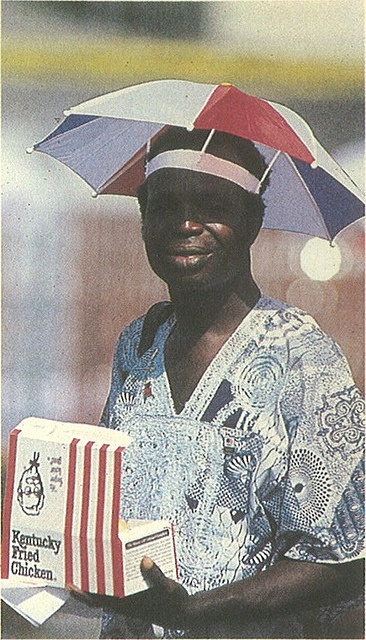Describe the objects in this image and their specific colors. I can see people in lightyellow, gray, lightgray, darkgray, and black tones and umbrella in lightyellow, darkgray, gray, lightgray, and brown tones in this image. 